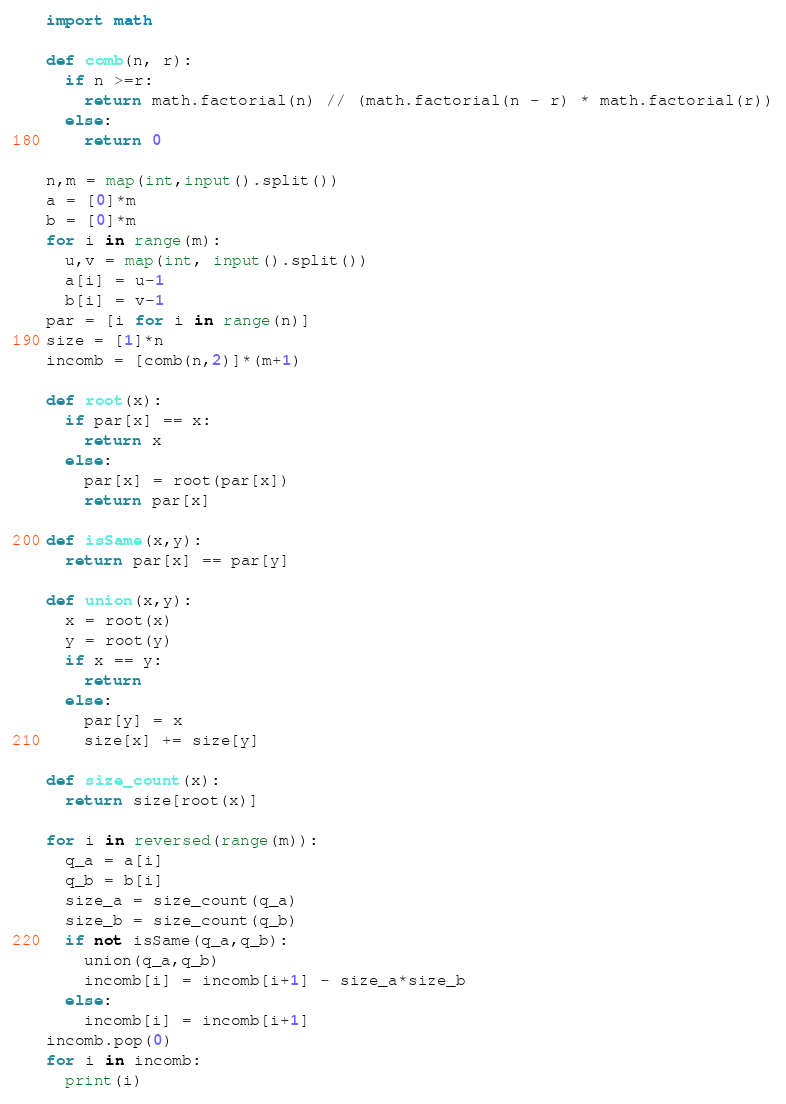Convert code to text. <code><loc_0><loc_0><loc_500><loc_500><_Python_>import math

def comb(n, r):
  if n >=r:
    return math.factorial(n) // (math.factorial(n - r) * math.factorial(r))
  else:
    return 0
      
n,m = map(int,input().split())
a = [0]*m
b = [0]*m
for i in range(m):
  u,v = map(int, input().split())
  a[i] = u-1
  b[i] = v-1
par = [i for i in range(n)]
size = [1]*n
incomb = [comb(n,2)]*(m+1)

def root(x):
  if par[x] == x: 
    return x
  else:
    par[x] = root(par[x])
    return par[x]
    
def isSame(x,y):
  return par[x] == par[y]

def union(x,y):
  x = root(x)
  y = root(y)
  if x == y:
    return
  else:
    par[y] = x
    size[x] += size[y]
    
def size_count(x):
  return size[root(x)]

for i in reversed(range(m)):
  q_a = a[i]
  q_b = b[i]
  size_a = size_count(q_a)
  size_b = size_count(q_b)
  if not isSame(q_a,q_b):
    union(q_a,q_b)
    incomb[i] = incomb[i+1] - size_a*size_b
  else:
    incomb[i] = incomb[i+1]
incomb.pop(0)
for i in incomb:
  print(i)</code> 